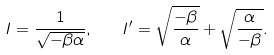Convert formula to latex. <formula><loc_0><loc_0><loc_500><loc_500>I = \frac { 1 } { \sqrt { - \beta \alpha } } , \quad I ^ { \prime } = \sqrt { \frac { - \beta } { \alpha } } + \sqrt { \frac { \alpha } { - \beta } } .</formula> 